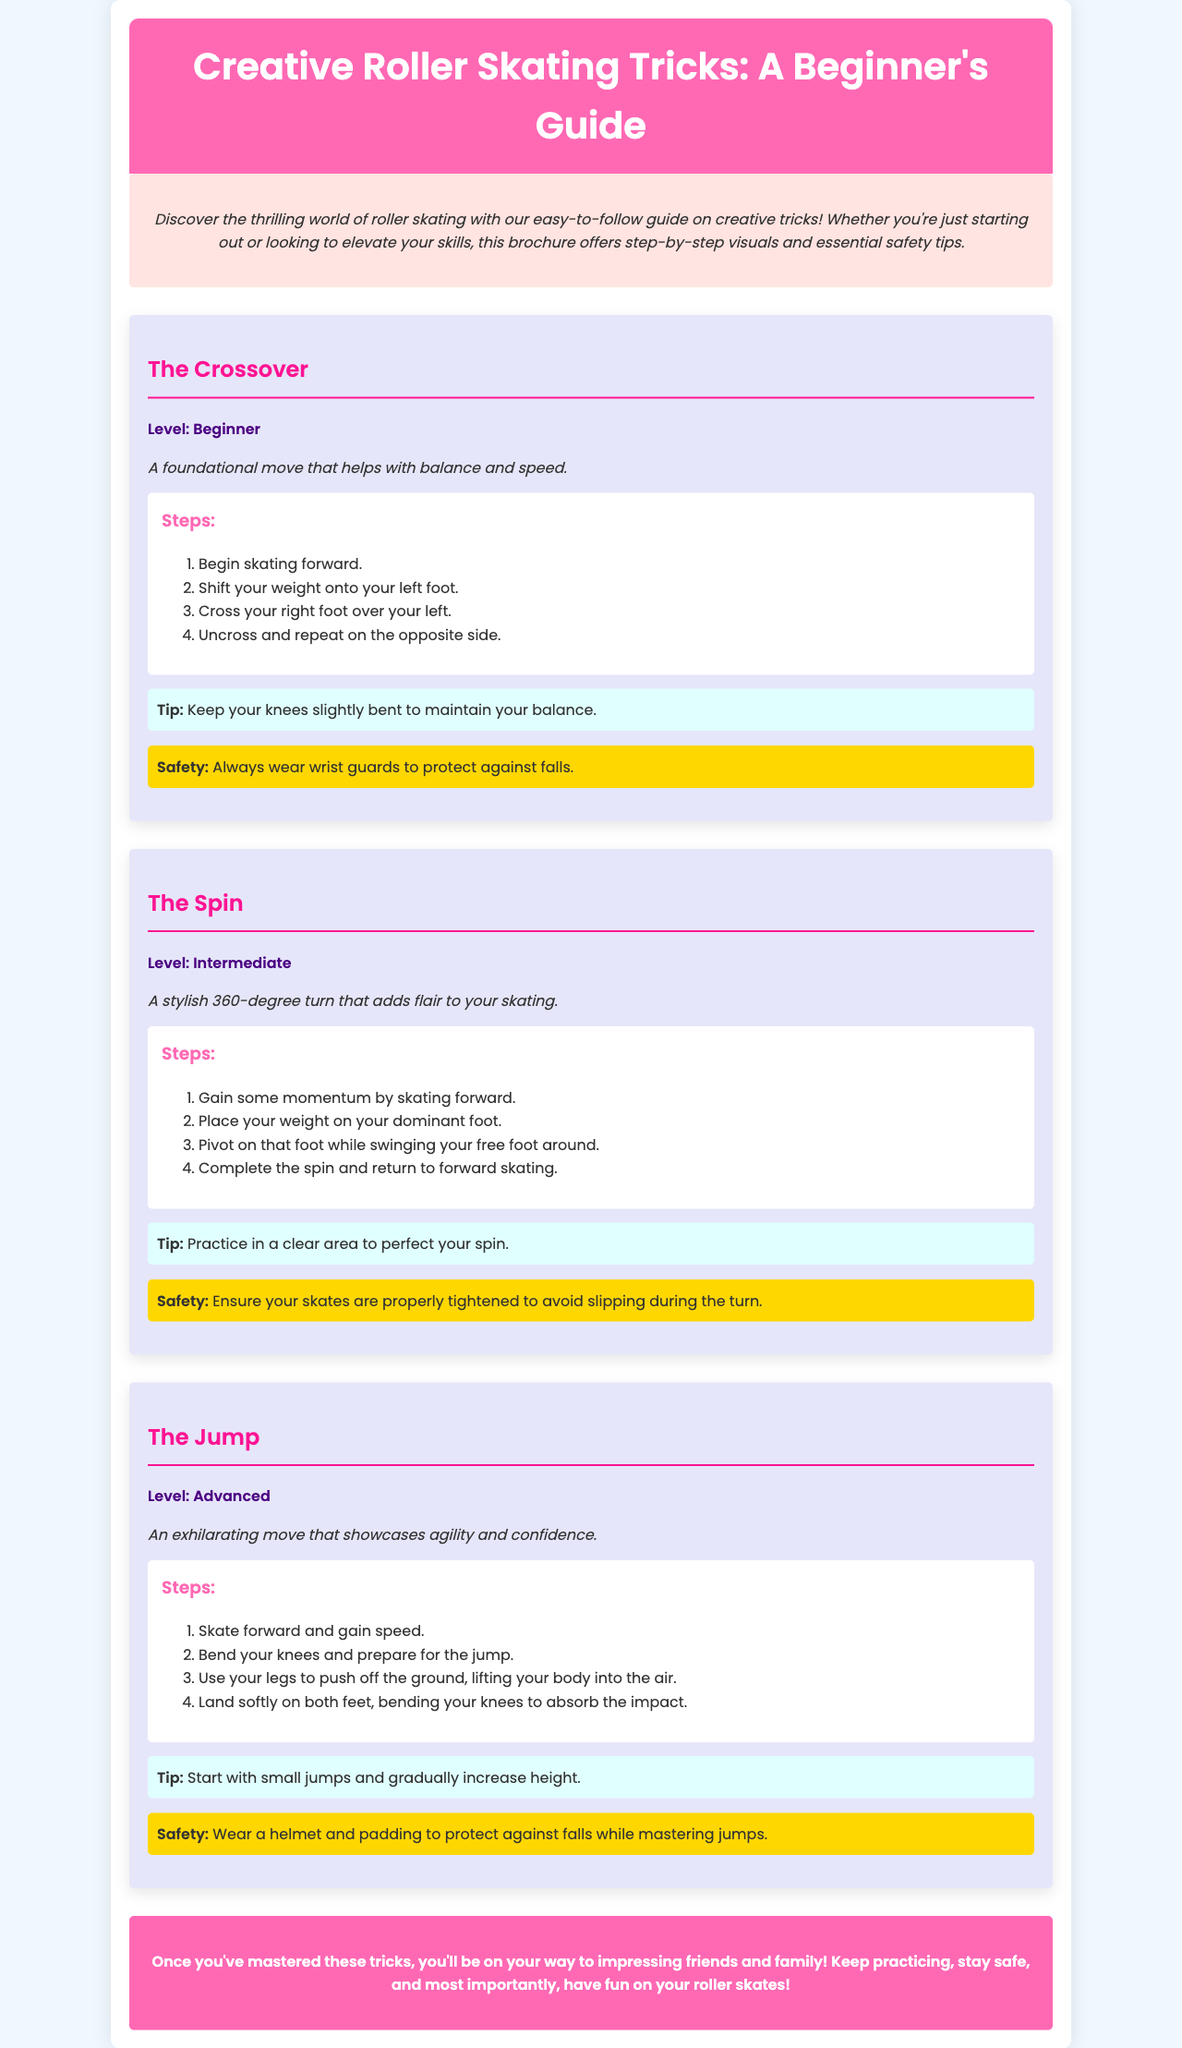what is the title of the brochure? The title of the brochure is prominently placed at the top and is "Creative Roller Skating Tricks: A Beginner's Guide."
Answer: Creative Roller Skating Tricks: A Beginner's Guide what is the level of "The Crossover" trick? The level of "The Crossover" trick is indicated directly below its title.
Answer: Beginner which trick is described as an exhilarating move? The document provides descriptions for each trick, and "The Jump" is specifically highlighted as exhilarating.
Answer: The Jump how many steps are in "The Spin" trick? The document lists the steps for "The Spin," which consists of four sequential steps.
Answer: 4 what is a safety tip for performing "The Jump"? The safety section for "The Jump" states essential precautions for safety during execution.
Answer: Wear a helmet and padding what is the primary focus of the brochure? The introduction outlines the central theme of the document centered around learning tricks in roller skating.
Answer: Creative tricks what style of font is used in the brochure? The font choice for the text throughout the brochure is mentioned in the style section.
Answer: Poppins what color is the background of the conclusion section? The conclusion section's background color is specified within the styling details of the document.
Answer: #ff69b4 